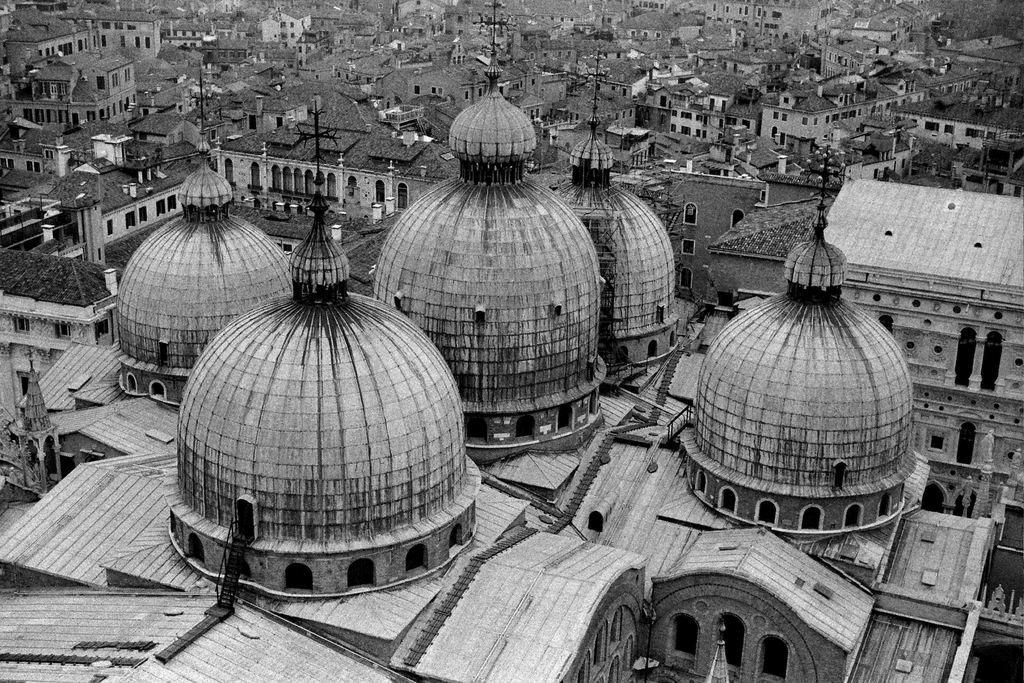What type of structures can be seen in the image? There are houses in the image. What color scheme is used in the image? The image is in black and white color. What book is the person reading in the image? There is no person or book present in the image; it only features houses in black and white. 